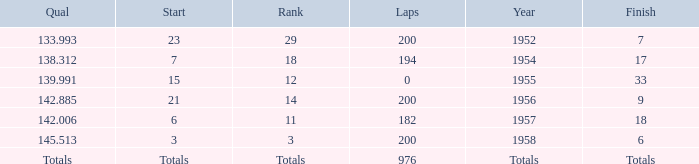Write the full table. {'header': ['Qual', 'Start', 'Rank', 'Laps', 'Year', 'Finish'], 'rows': [['133.993', '23', '29', '200', '1952', '7'], ['138.312', '7', '18', '194', '1954', '17'], ['139.991', '15', '12', '0', '1955', '33'], ['142.885', '21', '14', '200', '1956', '9'], ['142.006', '6', '11', '182', '1957', '18'], ['145.513', '3', '3', '200', '1958', '6'], ['Totals', 'Totals', 'Totals', '976', 'Totals', 'Totals']]} What place did Jimmy Reece start from when he ranked 12? 15.0. 